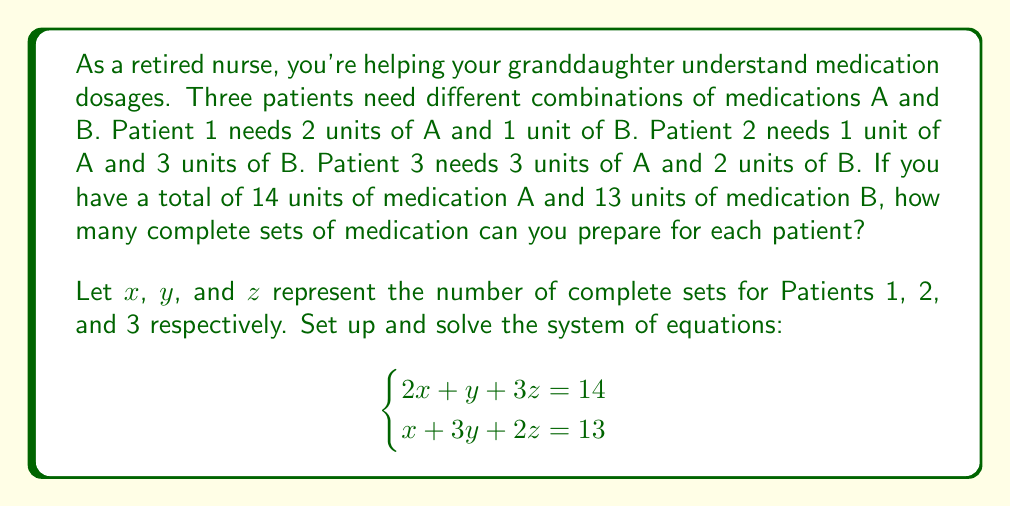What is the answer to this math problem? Let's solve this system of equations step by step:

1) We have two equations:
   $$2x + y + 3z = 14$$ (Equation 1)
   $$x + 3y + 2z = 13$$ (Equation 2)

2) Multiply Equation 2 by 2:
   $$2x + 6y + 4z = 26$$ (Equation 3)

3) Subtract Equation 1 from Equation 3:
   $$5y + z = 12$$ (Equation 4)

4) Multiply Equation 1 by 3:
   $$6x + 3y + 9z = 42$$ (Equation 5)

5) Subtract Equation 5 from 2 times Equation 3:
   $$9y - z = 10$$ (Equation 6)

6) Add Equation 4 and Equation 6:
   $$14y = 22$$
   $$y = \frac{22}{14} = \frac{11}{7}$$

7) Since $y$ must be a whole number (we can't prepare fractional sets), the largest possible value for $y$ is 1.

8) Substitute $y = 1$ into Equation 4:
   $$5(1) + z = 12$$
   $$z = 7$$

9) Substitute $y = 1$ and $z = 7$ into Equation 1:
   $$2x + 1 + 3(7) = 14$$
   $$2x + 22 = 14$$
   $$2x = -8$$
   $$x = -4$$

10) Since $x$ cannot be negative, we need to reduce $z$. The largest possible value for $z$ that gives a non-negative $x$ is 4.

11) With $z = 4$, from Equation 1:
    $$2x + 1 + 3(4) = 14$$
    $$2x + 13 = 14$$
    $$2x = 1$$
    $$x = \frac{1}{2}$$

12) The largest whole number value for $x$ is 0.

Therefore, the maximum number of complete sets that can be prepared is:
$x = 0$ (Patient 1), $y = 1$ (Patient 2), $z = 4$ (Patient 3)
Answer: $(0, 1, 4)$ 